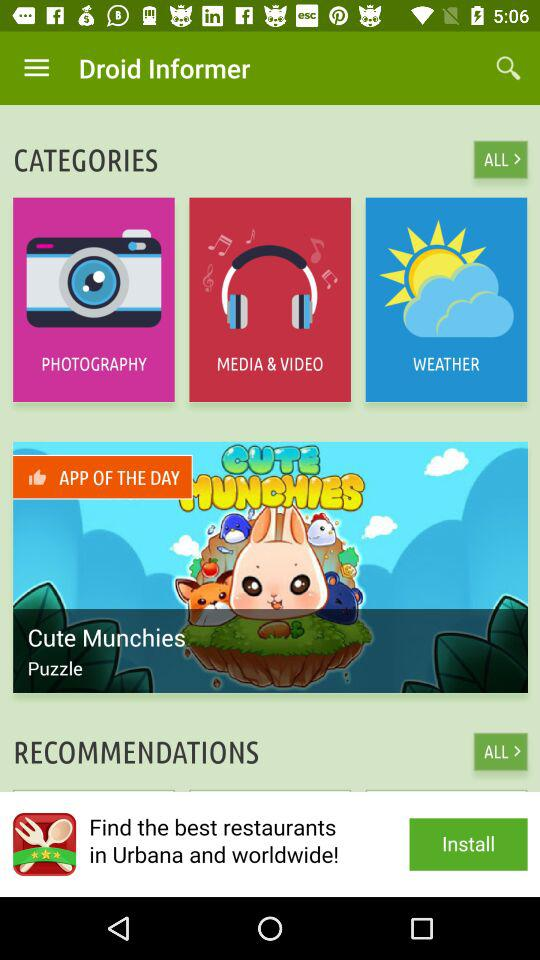What is the name of the application? The name of the application is "Droid Informer". 